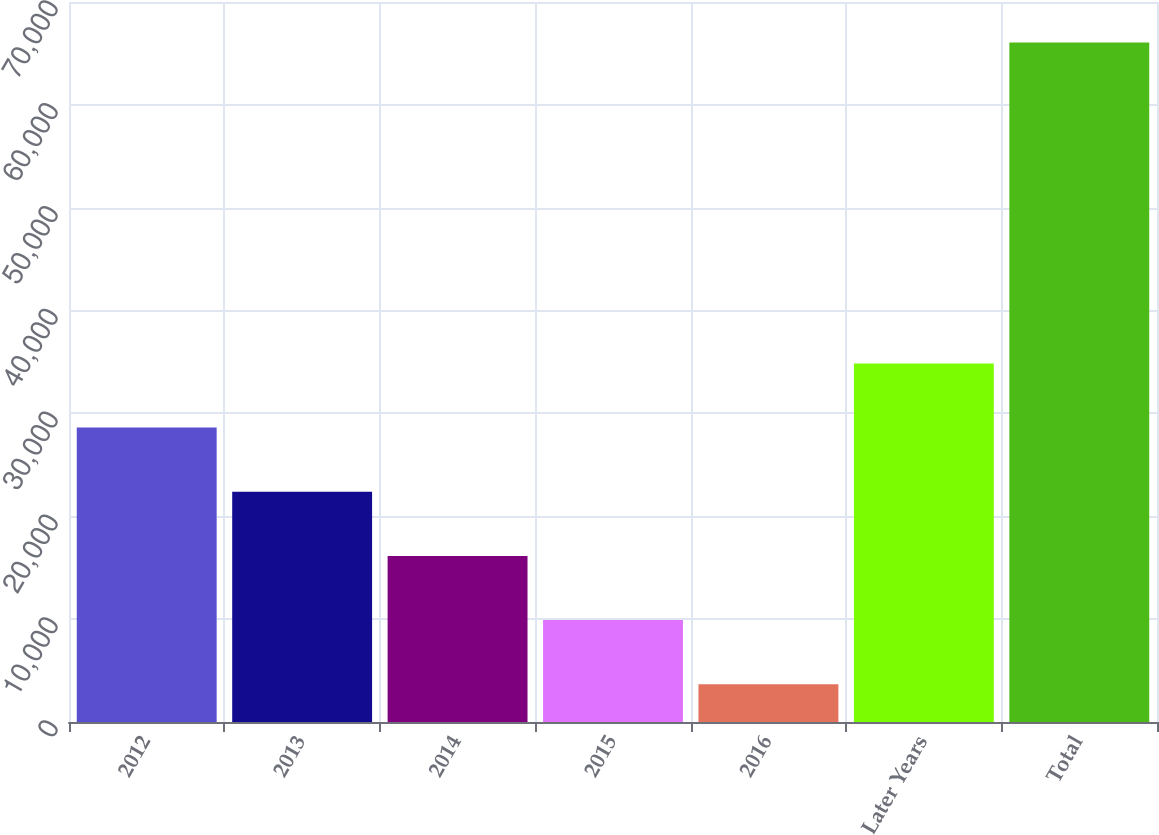<chart> <loc_0><loc_0><loc_500><loc_500><bar_chart><fcel>2012<fcel>2013<fcel>2014<fcel>2015<fcel>2016<fcel>Later Years<fcel>Total<nl><fcel>28623.4<fcel>22384.8<fcel>16146.2<fcel>9907.6<fcel>3669<fcel>34862<fcel>66055<nl></chart> 